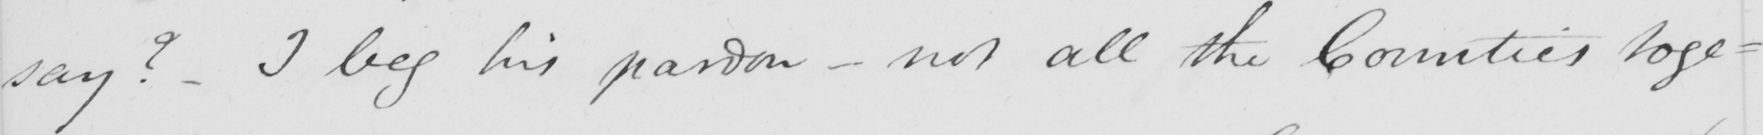Please provide the text content of this handwritten line. say ?  I beg his pardon  _  not all the Counties toge- 